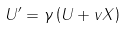<formula> <loc_0><loc_0><loc_500><loc_500>U ^ { \prime } = \gamma \left ( U + v X \right )</formula> 